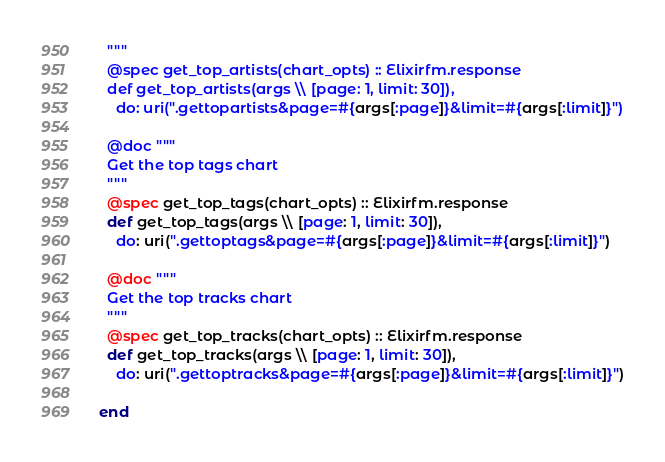Convert code to text. <code><loc_0><loc_0><loc_500><loc_500><_Elixir_>  """
  @spec get_top_artists(chart_opts) :: Elixirfm.response
  def get_top_artists(args \\ [page: 1, limit: 30]),
    do: uri(".gettopartists&page=#{args[:page]}&limit=#{args[:limit]}")

  @doc """
  Get the top tags chart
  """
  @spec get_top_tags(chart_opts) :: Elixirfm.response
  def get_top_tags(args \\ [page: 1, limit: 30]),
    do: uri(".gettoptags&page=#{args[:page]}&limit=#{args[:limit]}")

  @doc """
  Get the top tracks chart
  """
  @spec get_top_tracks(chart_opts) :: Elixirfm.response
  def get_top_tracks(args \\ [page: 1, limit: 30]),
    do: uri(".gettoptracks&page=#{args[:page]}&limit=#{args[:limit]}")

end
</code> 